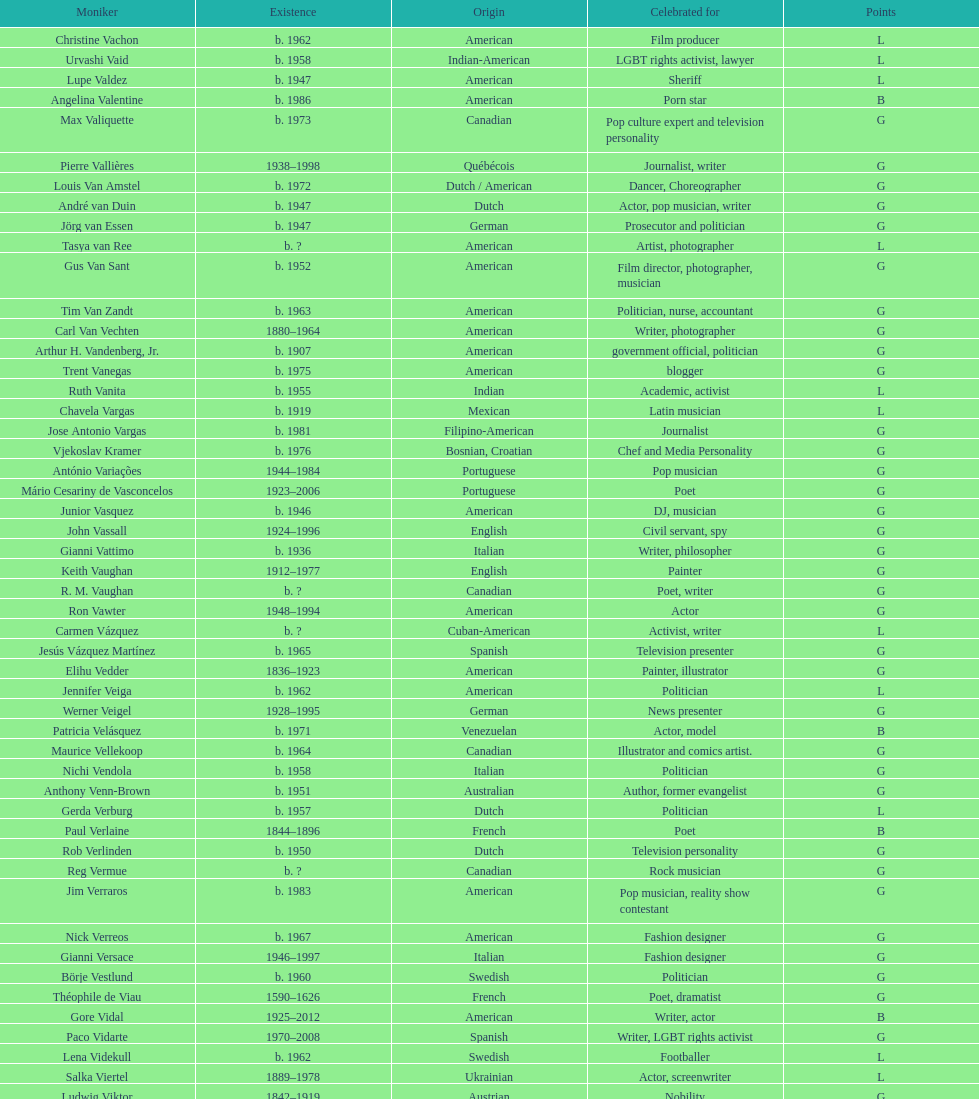Who lived longer, van vechten or variacoes? Van Vechten. 